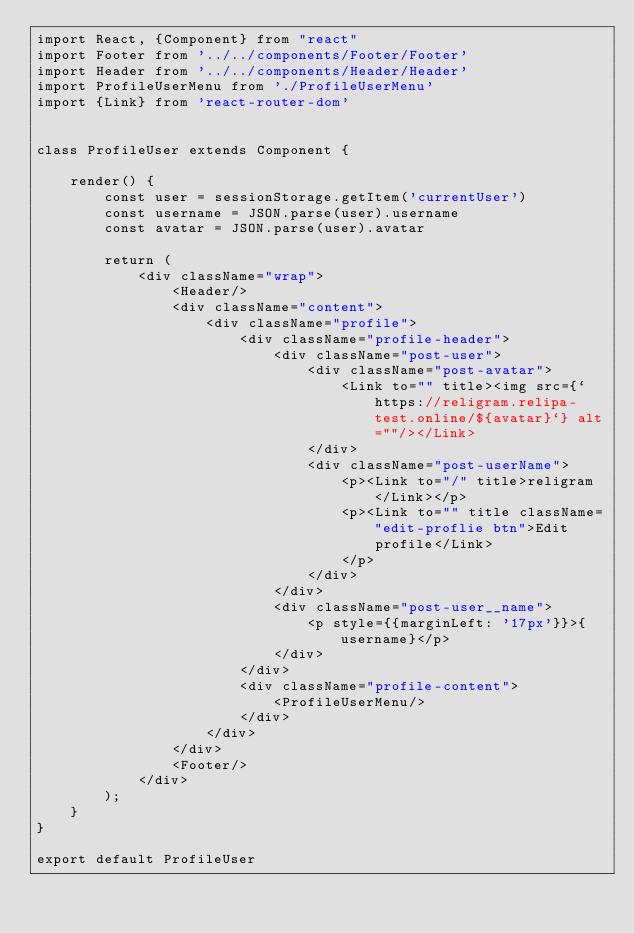Convert code to text. <code><loc_0><loc_0><loc_500><loc_500><_JavaScript_>import React, {Component} from "react"
import Footer from '../../components/Footer/Footer'
import Header from '../../components/Header/Header'
import ProfileUserMenu from './ProfileUserMenu'
import {Link} from 'react-router-dom'


class ProfileUser extends Component {

    render() {
        const user = sessionStorage.getItem('currentUser')
        const username = JSON.parse(user).username
        const avatar = JSON.parse(user).avatar

        return (
            <div className="wrap">
                <Header/>
                <div className="content">
                    <div className="profile">
                        <div className="profile-header">
                            <div className="post-user">
                                <div className="post-avatar">
                                    <Link to="" title><img src={`https://religram.relipa-test.online/${avatar}`} alt=""/></Link>
                                </div>
                                <div className="post-userName">
                                    <p><Link to="/" title>religram</Link></p>
                                    <p><Link to="" title className="edit-proflie btn">Edit
                                        profile</Link>
                                    </p>
                                </div>
                            </div>
                            <div className="post-user__name">
                                <p style={{marginLeft: '17px'}}>{username}</p>
                            </div>
                        </div>
                        <div className="profile-content">
                            <ProfileUserMenu/>
                        </div>
                    </div>
                </div>
                <Footer/>
            </div>
        );
    }
}

export default ProfileUser


</code> 